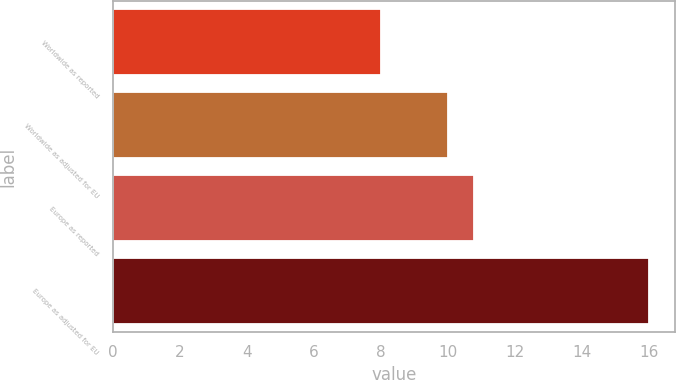<chart> <loc_0><loc_0><loc_500><loc_500><bar_chart><fcel>Worldwide as reported<fcel>Worldwide as adjusted for EU<fcel>Europe as reported<fcel>Europe as adjusted for EU<nl><fcel>8<fcel>10<fcel>10.8<fcel>16<nl></chart> 